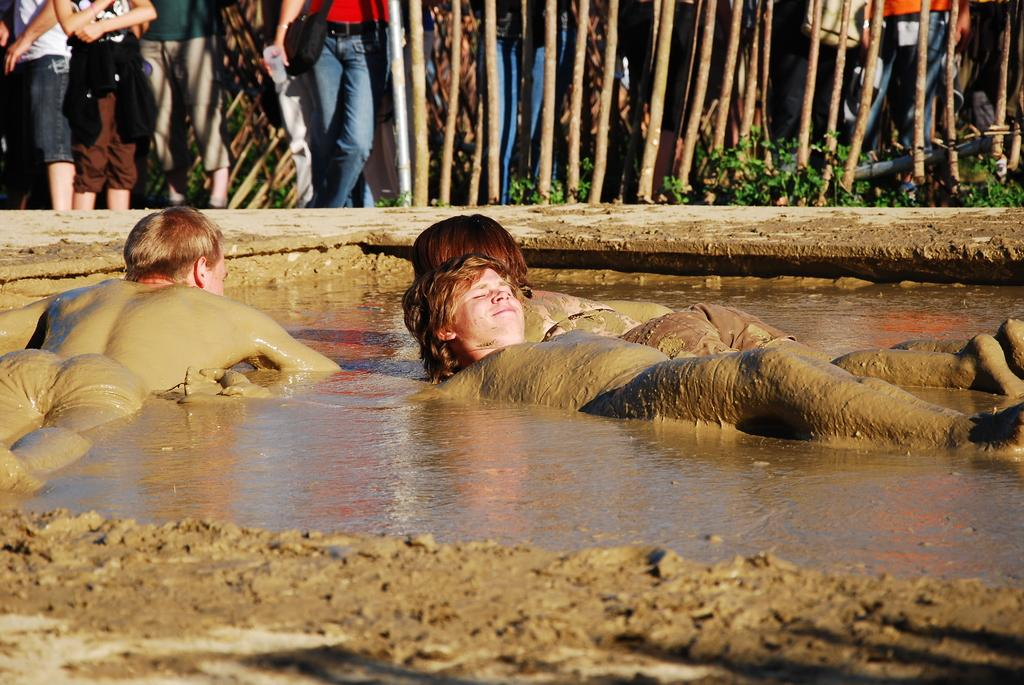How many people are present in the image? There are 3 people in the image. What are the people doing in the image? The people are lying in the water. Can you describe the appearance of the water in the image? The water appears to be muddy. What type of hose is being used to clean the book in the image? There is no hose or book present in the image; it features people lying in muddy water. 